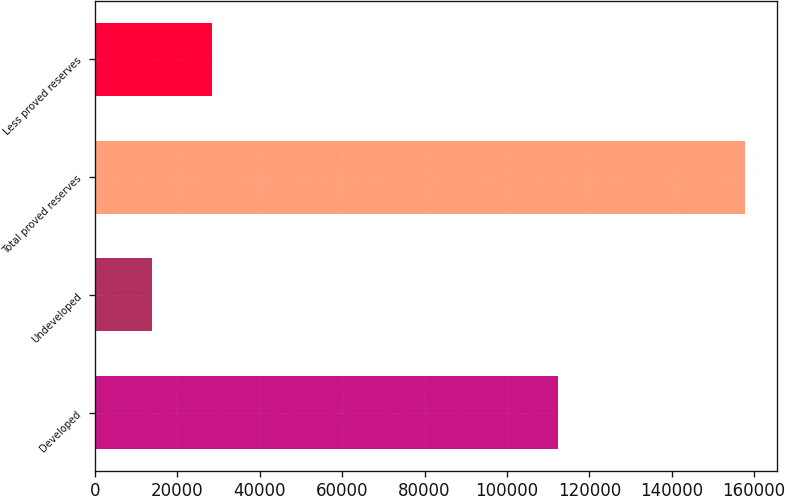Convert chart to OTSL. <chart><loc_0><loc_0><loc_500><loc_500><bar_chart><fcel>Developed<fcel>Undeveloped<fcel>Total proved reserves<fcel>Less proved reserves<nl><fcel>112376<fcel>13968<fcel>157689<fcel>28340.1<nl></chart> 